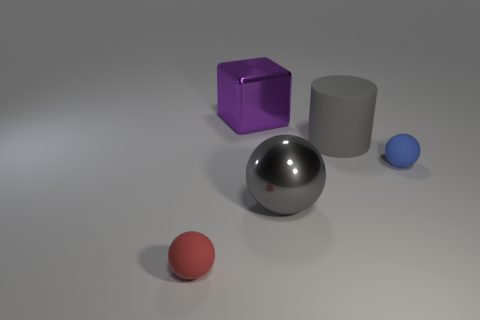There is a sphere that is the same color as the cylinder; what is its material?
Give a very brief answer. Metal. Is there another big block of the same color as the large shiny cube?
Give a very brief answer. No. What is the shape of the red matte object that is the same size as the blue thing?
Keep it short and to the point. Sphere. There is a big metallic object on the right side of the purple block; how many matte things are on the right side of it?
Make the answer very short. 2. Is the big metal ball the same color as the cylinder?
Offer a terse response. Yes. How many other things are there of the same material as the big purple object?
Your answer should be very brief. 1. What shape is the tiny object that is on the right side of the matte sphere left of the big gray matte thing?
Provide a short and direct response. Sphere. What is the size of the gray object that is behind the tiny blue thing?
Give a very brief answer. Large. Do the large purple cube and the tiny red object have the same material?
Give a very brief answer. No. The big gray object that is made of the same material as the big cube is what shape?
Your answer should be very brief. Sphere. 